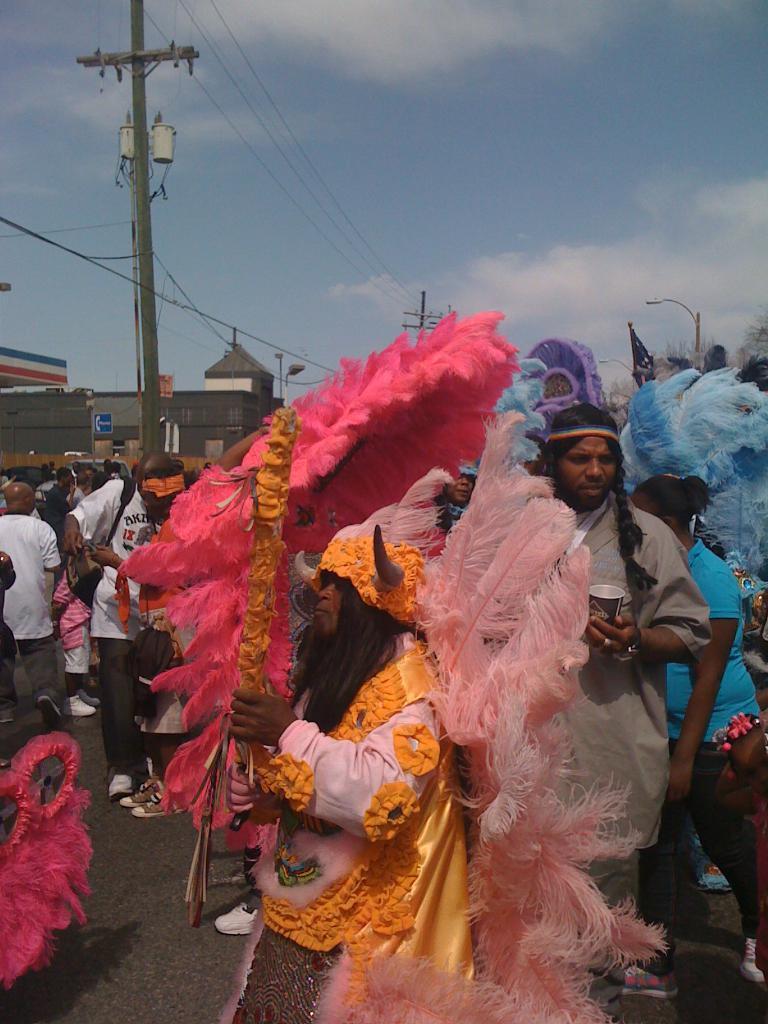Could you give a brief overview of what you see in this image? In the image in the center, we can see a few people are standing and they are holding some objects. And they are in different costumes. In the background, we can see the sky, clouds, buildings, poles, wires, sign boards etc. 